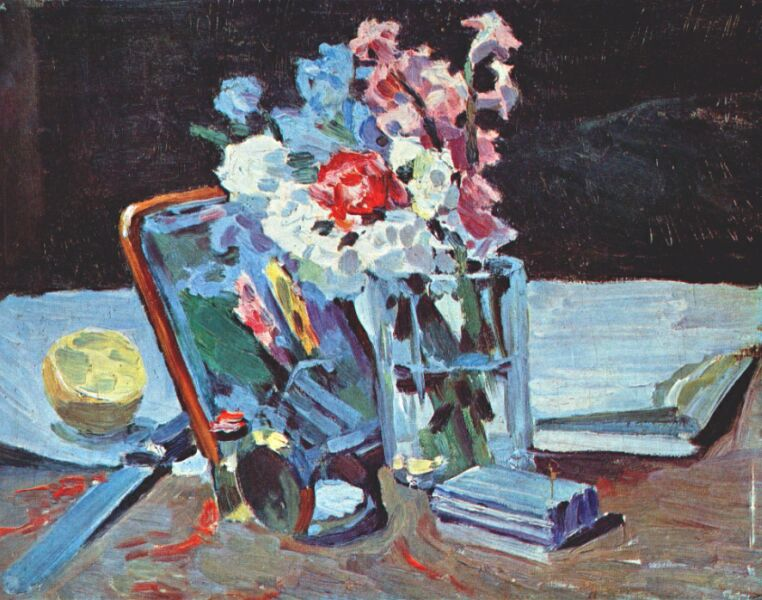What might the selection of items in this image suggest about the person who arranged them? The choice of objects seems to be quite personal and perhaps reflective of the individual's tastes and interests. The presence of books might indicate a love for reading or scholarship. The glass ball could imply an appreciation for simple, yet beautiful objects that play with light. The flowers, carefully chosen and arranged in a vase, suggest a love for natural beauty and perhaps a moment taken for oneself in an otherwise busy life. The way these items are scattered could allude to a sense of casualness or comfort within one’s own space, revealing a personality that enjoys both structure and spontaneity. 